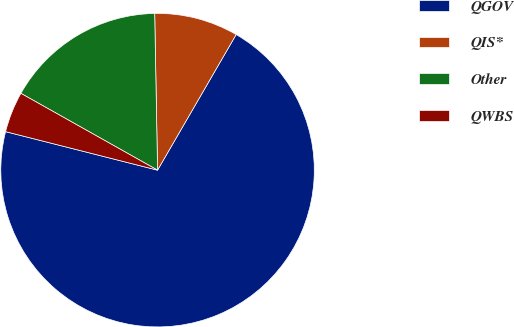<chart> <loc_0><loc_0><loc_500><loc_500><pie_chart><fcel>QGOV<fcel>QIS*<fcel>Other<fcel>QWBS<nl><fcel>70.59%<fcel>8.65%<fcel>16.56%<fcel>4.2%<nl></chart> 